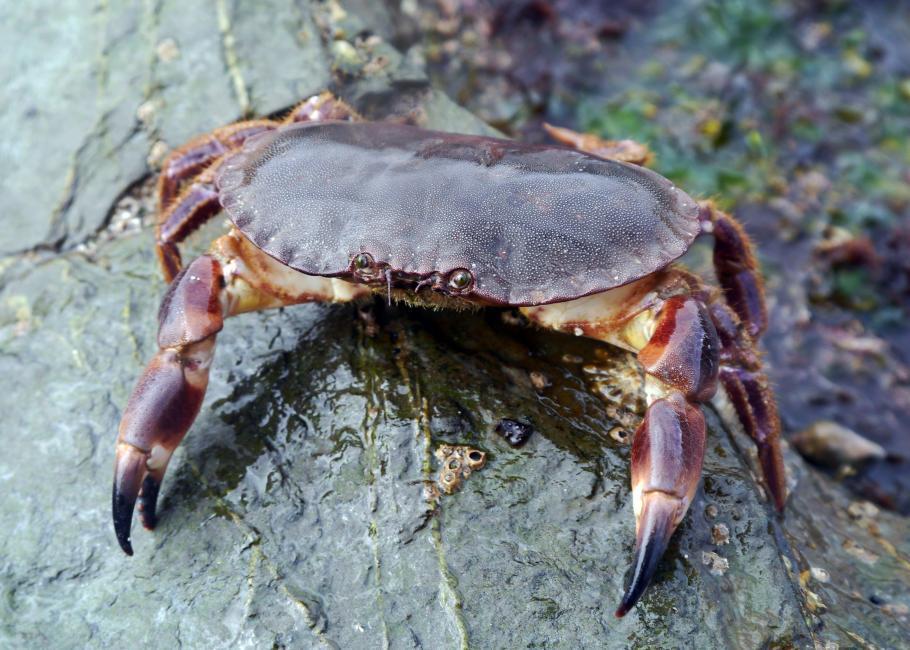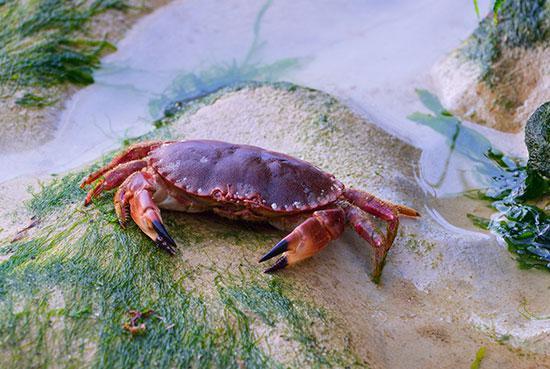The first image is the image on the left, the second image is the image on the right. Given the left and right images, does the statement "Each image shows one purple crab with dark-tipped front claws that is facing the camera." hold true? Answer yes or no. Yes. The first image is the image on the left, the second image is the image on the right. Assess this claim about the two images: "The tips of every crab's claws are noticeably black.". Correct or not? Answer yes or no. Yes. 